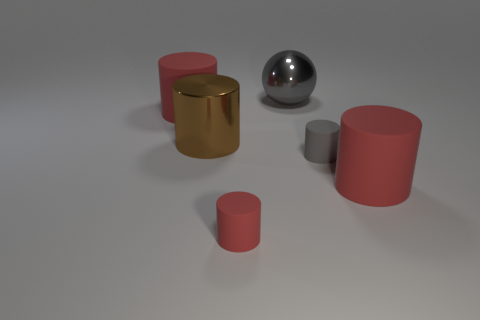Subtract all small cylinders. How many cylinders are left? 3 Add 4 tiny red metallic blocks. How many objects exist? 10 Subtract all red cylinders. How many cylinders are left? 2 Subtract all cylinders. How many objects are left? 1 Subtract all blue blocks. How many red cylinders are left? 3 Subtract all cyan cylinders. Subtract all brown spheres. How many cylinders are left? 5 Subtract all tiny yellow metallic cylinders. Subtract all brown metal cylinders. How many objects are left? 5 Add 1 large balls. How many large balls are left? 2 Add 2 large gray matte cubes. How many large gray matte cubes exist? 2 Subtract 0 brown spheres. How many objects are left? 6 